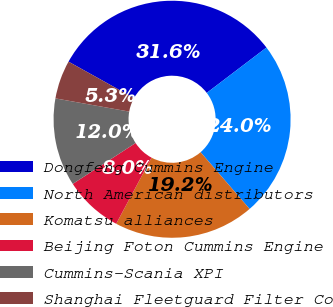Convert chart to OTSL. <chart><loc_0><loc_0><loc_500><loc_500><pie_chart><fcel>Dongfeng Cummins Engine<fcel>North American distributors<fcel>Komatsu alliances<fcel>Beijing Foton Cummins Engine<fcel>Cummins-Scania XPI<fcel>Shanghai Fleetguard Filter Co<nl><fcel>31.58%<fcel>24.0%<fcel>19.16%<fcel>8.0%<fcel>12.0%<fcel>5.26%<nl></chart> 